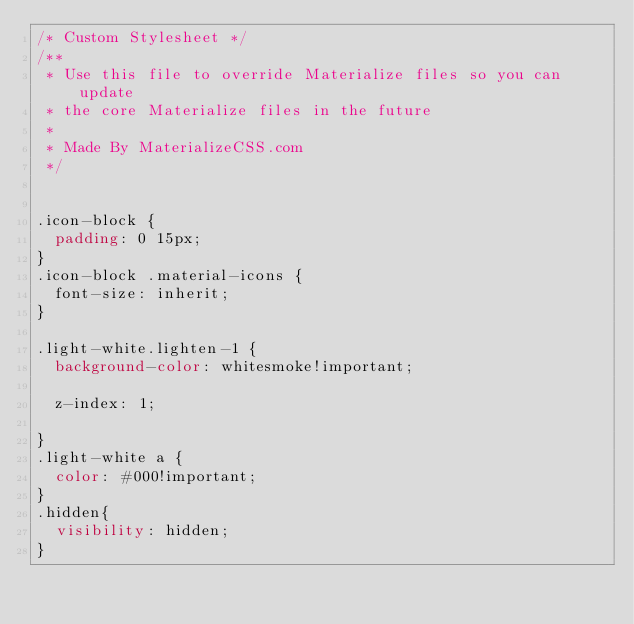<code> <loc_0><loc_0><loc_500><loc_500><_CSS_>/* Custom Stylesheet */
/**
 * Use this file to override Materialize files so you can update
 * the core Materialize files in the future
 *
 * Made By MaterializeCSS.com
 */


.icon-block {
  padding: 0 15px;
}
.icon-block .material-icons {
	font-size: inherit;
}

.light-white.lighten-1 {
  background-color: whitesmoke!important;

  z-index: 1;
  
}
.light-white a {
  color: #000!important;
}
.hidden{
  visibility: hidden;
}
</code> 